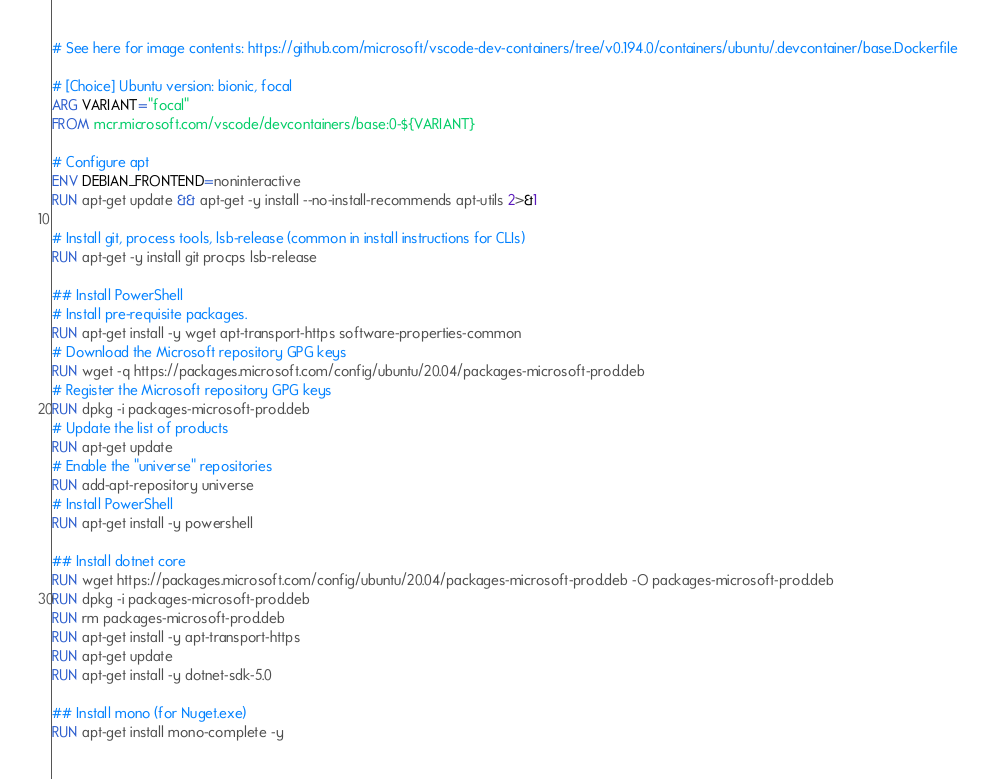<code> <loc_0><loc_0><loc_500><loc_500><_Dockerfile_># See here for image contents: https://github.com/microsoft/vscode-dev-containers/tree/v0.194.0/containers/ubuntu/.devcontainer/base.Dockerfile

# [Choice] Ubuntu version: bionic, focal
ARG VARIANT="focal"
FROM mcr.microsoft.com/vscode/devcontainers/base:0-${VARIANT}

# Configure apt
ENV DEBIAN_FRONTEND=noninteractive
RUN apt-get update && apt-get -y install --no-install-recommends apt-utils 2>&1

# Install git, process tools, lsb-release (common in install instructions for CLIs)
RUN apt-get -y install git procps lsb-release

## Install PowerShell
# Install pre-requisite packages.
RUN apt-get install -y wget apt-transport-https software-properties-common
# Download the Microsoft repository GPG keys
RUN wget -q https://packages.microsoft.com/config/ubuntu/20.04/packages-microsoft-prod.deb
# Register the Microsoft repository GPG keys
RUN dpkg -i packages-microsoft-prod.deb
# Update the list of products
RUN apt-get update
# Enable the "universe" repositories
RUN add-apt-repository universe
# Install PowerShell
RUN apt-get install -y powershell

## Install dotnet core
RUN wget https://packages.microsoft.com/config/ubuntu/20.04/packages-microsoft-prod.deb -O packages-microsoft-prod.deb
RUN dpkg -i packages-microsoft-prod.deb
RUN rm packages-microsoft-prod.deb
RUN apt-get install -y apt-transport-https
RUN apt-get update
RUN apt-get install -y dotnet-sdk-5.0

## Install mono (for Nuget.exe)
RUN apt-get install mono-complete -y
</code> 